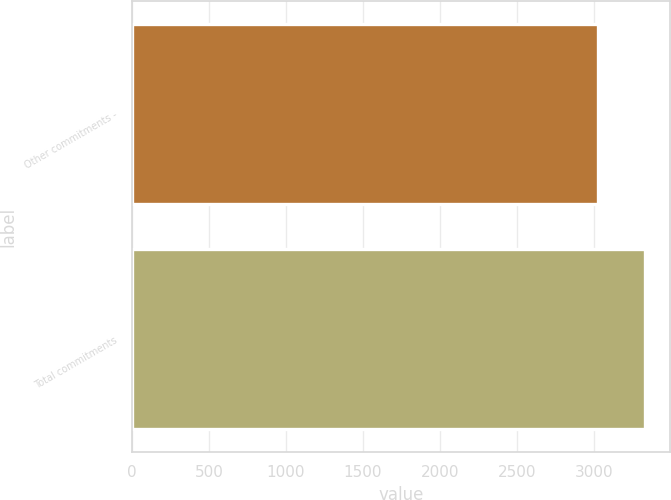Convert chart. <chart><loc_0><loc_0><loc_500><loc_500><bar_chart><fcel>Other commitments -<fcel>Total commitments<nl><fcel>3028<fcel>3330.8<nl></chart> 